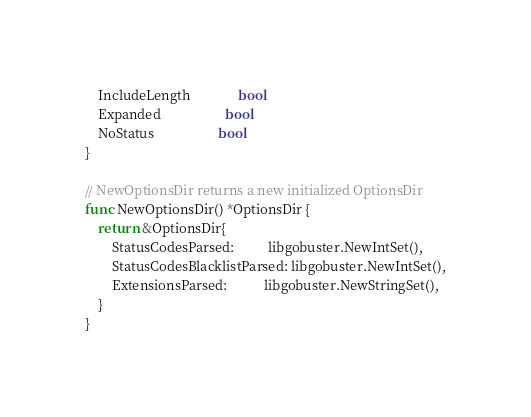Convert code to text. <code><loc_0><loc_0><loc_500><loc_500><_Go_>	IncludeLength              bool
	Expanded                   bool
	NoStatus                   bool
}

// NewOptionsDir returns a new initialized OptionsDir
func NewOptionsDir() *OptionsDir {
	return &OptionsDir{
		StatusCodesParsed:          libgobuster.NewIntSet(),
		StatusCodesBlacklistParsed: libgobuster.NewIntSet(),
		ExtensionsParsed:           libgobuster.NewStringSet(),
	}
}
</code> 